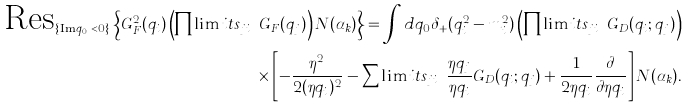Convert formula to latex. <formula><loc_0><loc_0><loc_500><loc_500>\text {Res} _ { \{ \text {Im} \, q _ { i 0 } < 0 \} } \left \{ G _ { F } ^ { 2 } ( q _ { i } ) \left ( \prod \lim i t s _ { j \neq i } G _ { F } ( q _ { j } ) \right ) N ( \alpha _ { k } ) \right \} = \int d q _ { 0 } \delta _ { + } ( q _ { i } ^ { 2 } - m _ { i } ^ { 2 } ) \left ( \prod \lim i t s _ { j \neq i } G _ { D } ( q _ { i } ; q _ { j } ) \right ) \\ \times \left [ - \frac { \eta ^ { 2 } } { 2 ( \eta q _ { i } ) ^ { 2 } } - \sum \lim i t s _ { j \neq i } \frac { \eta q _ { j } } { \eta q _ { i } } G _ { D } ( q _ { i } ; q _ { j } ) + \frac { 1 } { 2 \eta q _ { i } } \frac { \partial } { \partial \eta q _ { i } } \right ] N ( \alpha _ { k } ) .</formula> 